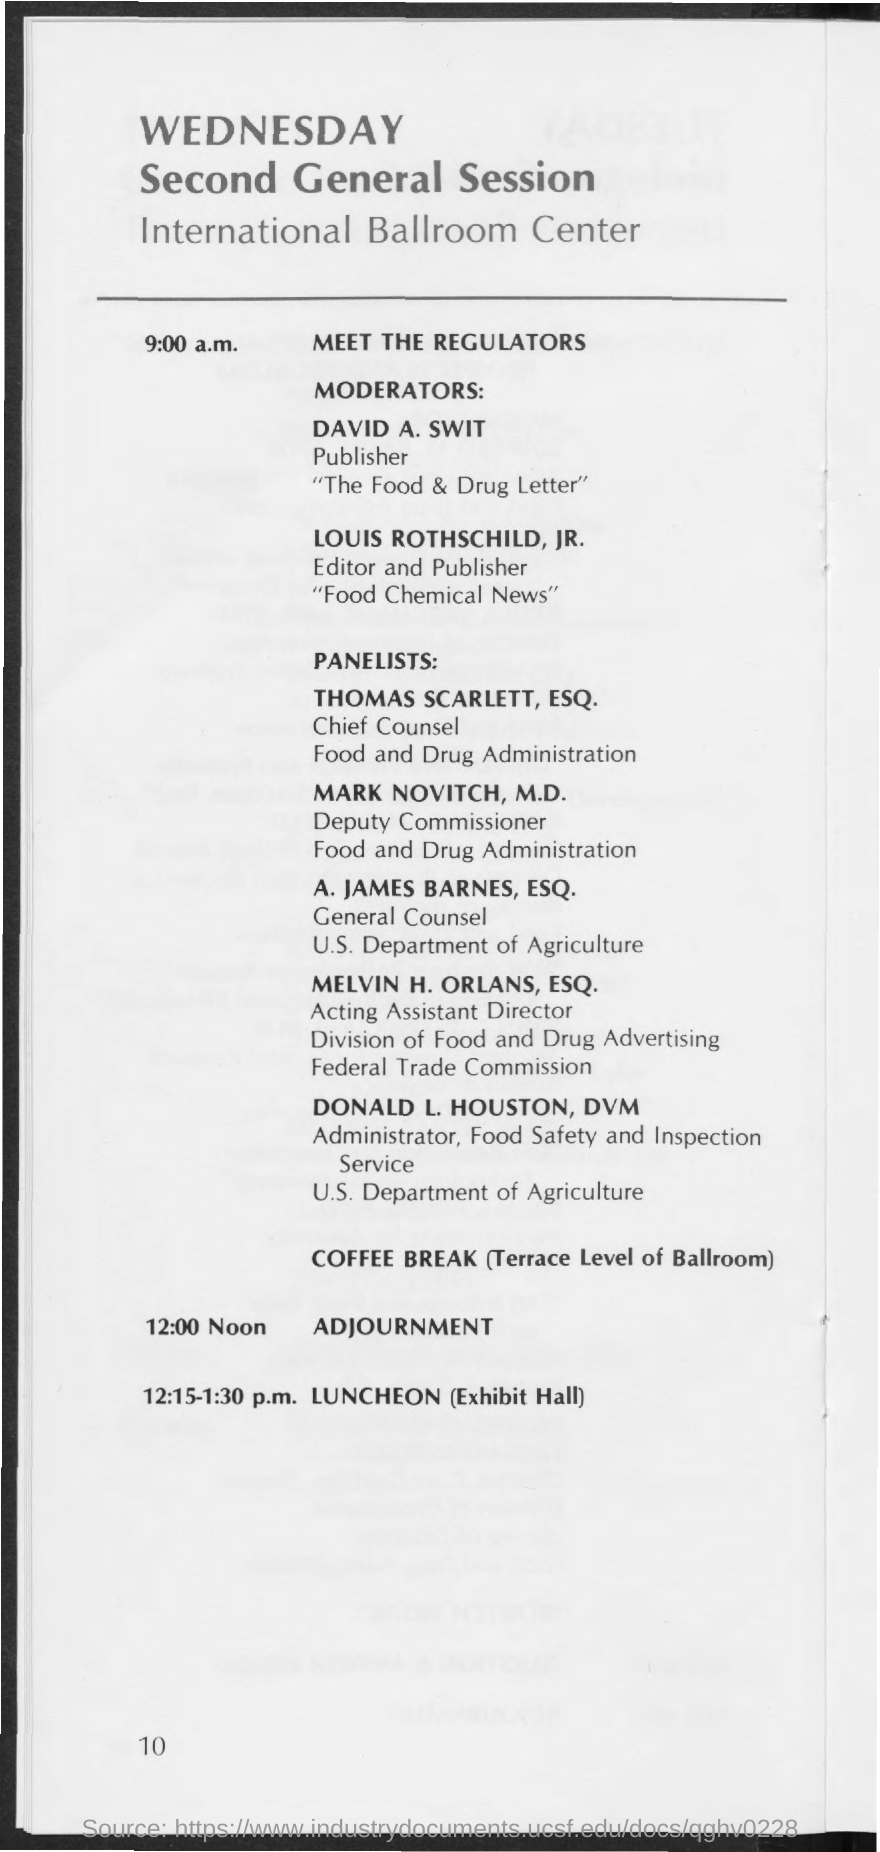When is the "meet the regulators"?
Your response must be concise. 9:00 a.m. When is the Adjournment?
Offer a terse response. 12:00 Noon. When is the Luncheon?
Provide a succinct answer. 12:15-1:30 p.m. 